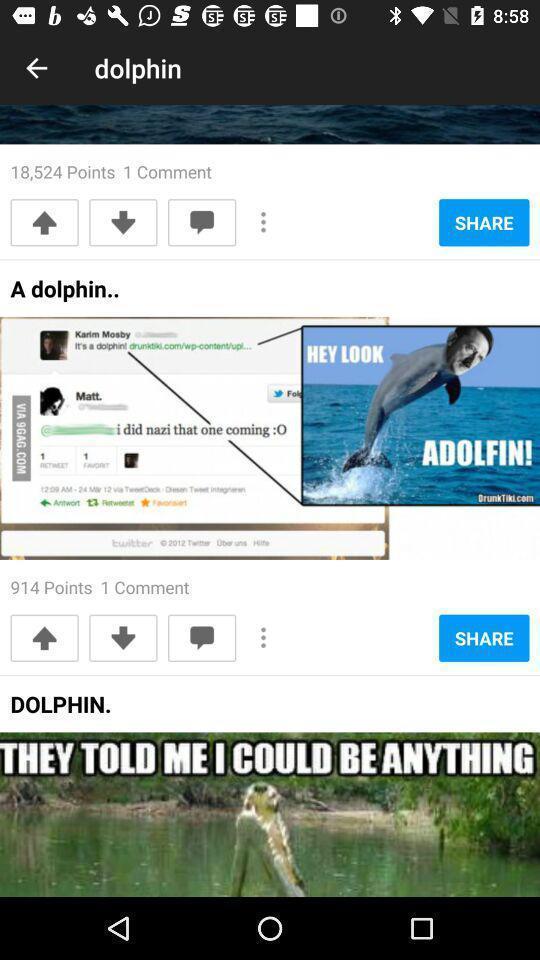Give me a summary of this screen capture. Screen showing points and comments. 